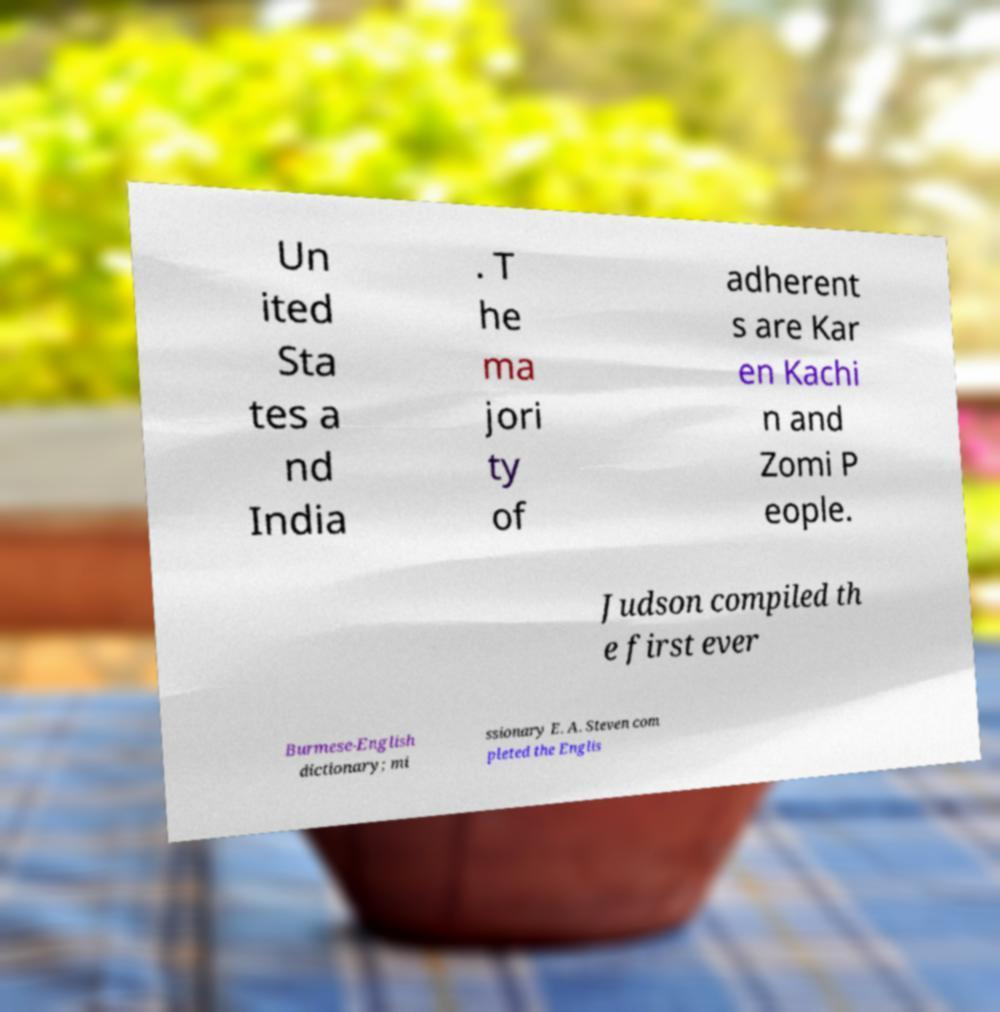For documentation purposes, I need the text within this image transcribed. Could you provide that? Un ited Sta tes a nd India . T he ma jori ty of adherent s are Kar en Kachi n and Zomi P eople. Judson compiled th e first ever Burmese-English dictionary; mi ssionary E. A. Steven com pleted the Englis 